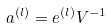<formula> <loc_0><loc_0><loc_500><loc_500>a ^ { ( l ) } & = e ^ { ( l ) } V ^ { - 1 }</formula> 